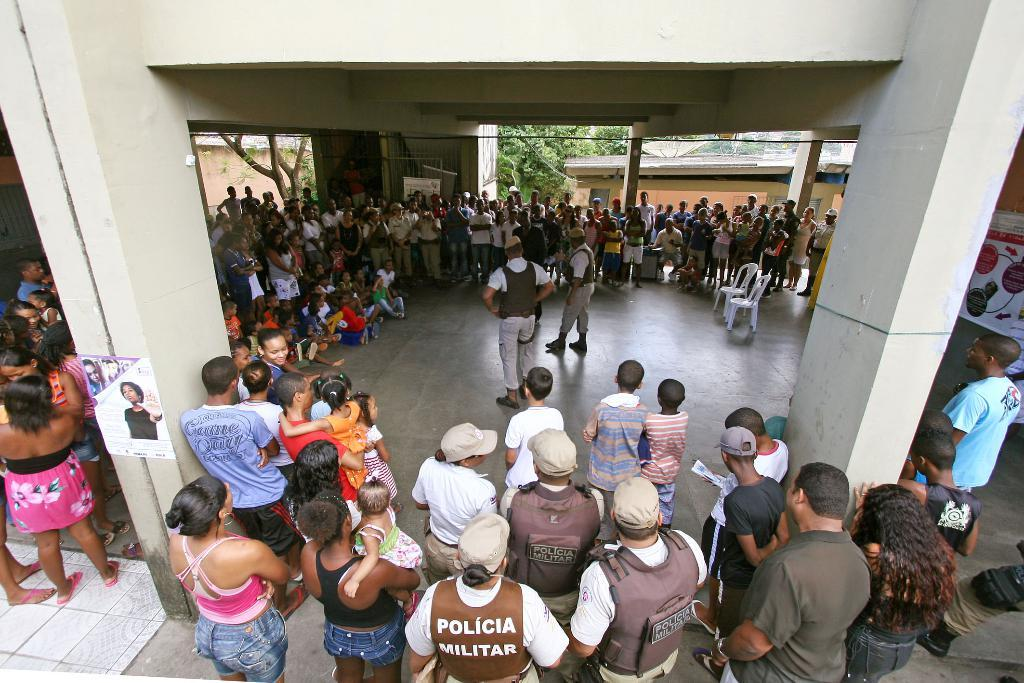What is the surface on which the lecture is taking place in the image? There is a floor in the image, and the lecture is taking place on it. Who are the individuals giving the lecture? Two persons are giving the lecture in the image. What can be observed about the audience in the image? There are people watching the lecture in the image. What can be seen in the background of the image? Trees are visible in the background of the image. What type of basin is being used for the discussion in the image? There is no basin present in the image, and the conversation is not about a discussion but a lecture. 